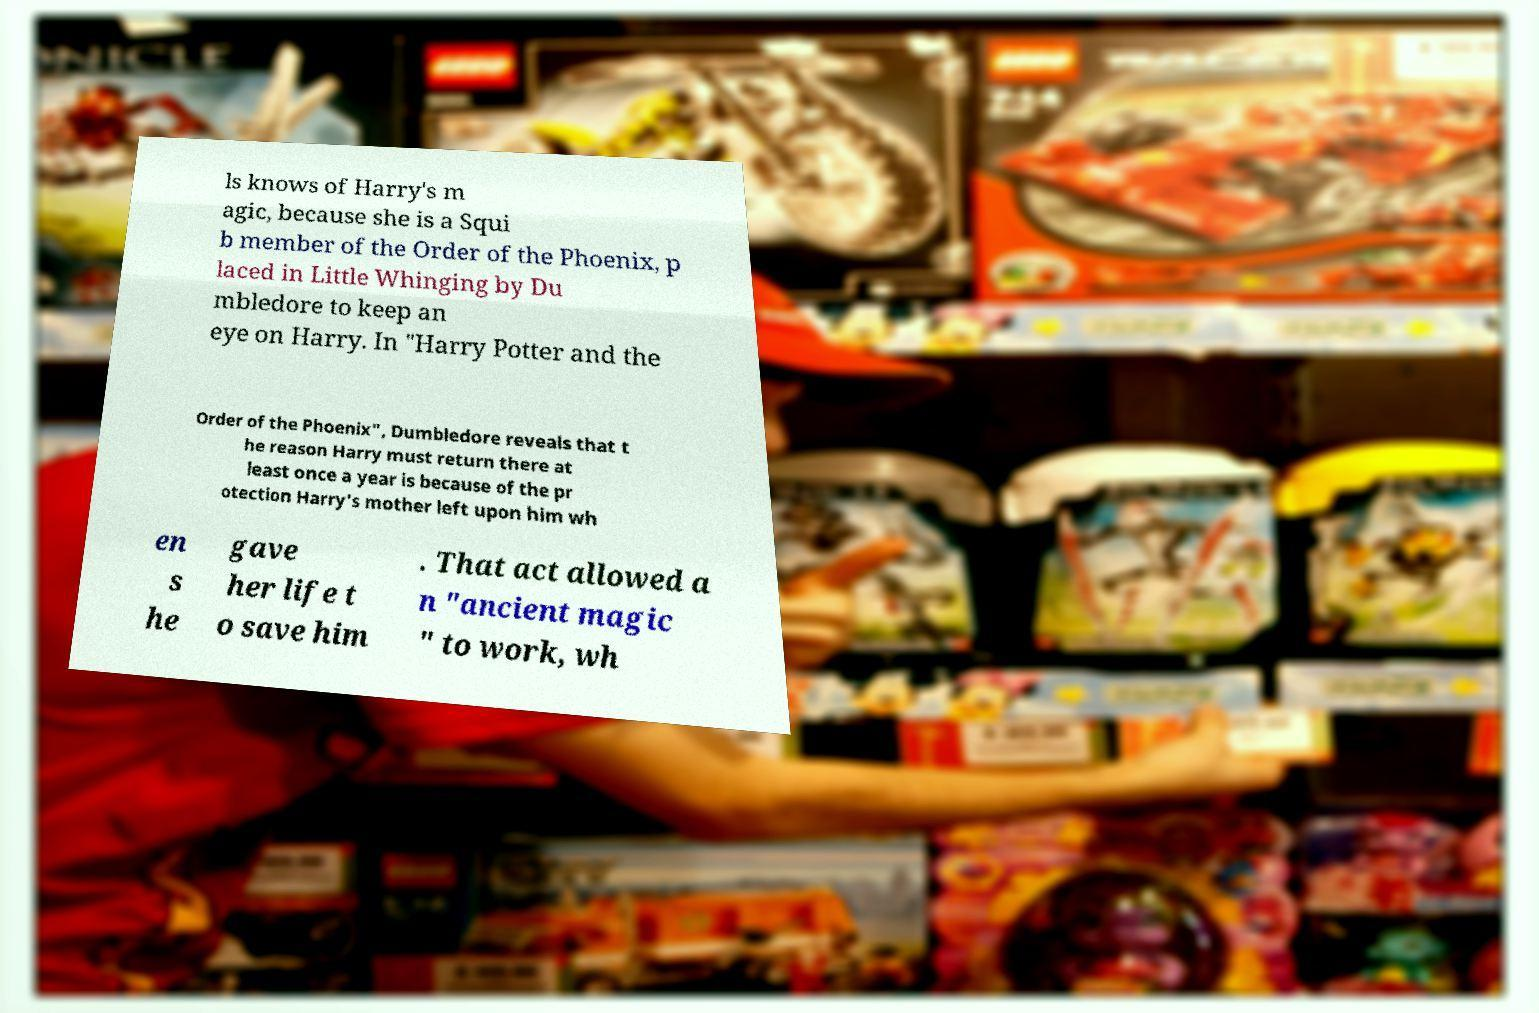Can you accurately transcribe the text from the provided image for me? ls knows of Harry's m agic, because she is a Squi b member of the Order of the Phoenix, p laced in Little Whinging by Du mbledore to keep an eye on Harry. In "Harry Potter and the Order of the Phoenix", Dumbledore reveals that t he reason Harry must return there at least once a year is because of the pr otection Harry's mother left upon him wh en s he gave her life t o save him . That act allowed a n "ancient magic " to work, wh 